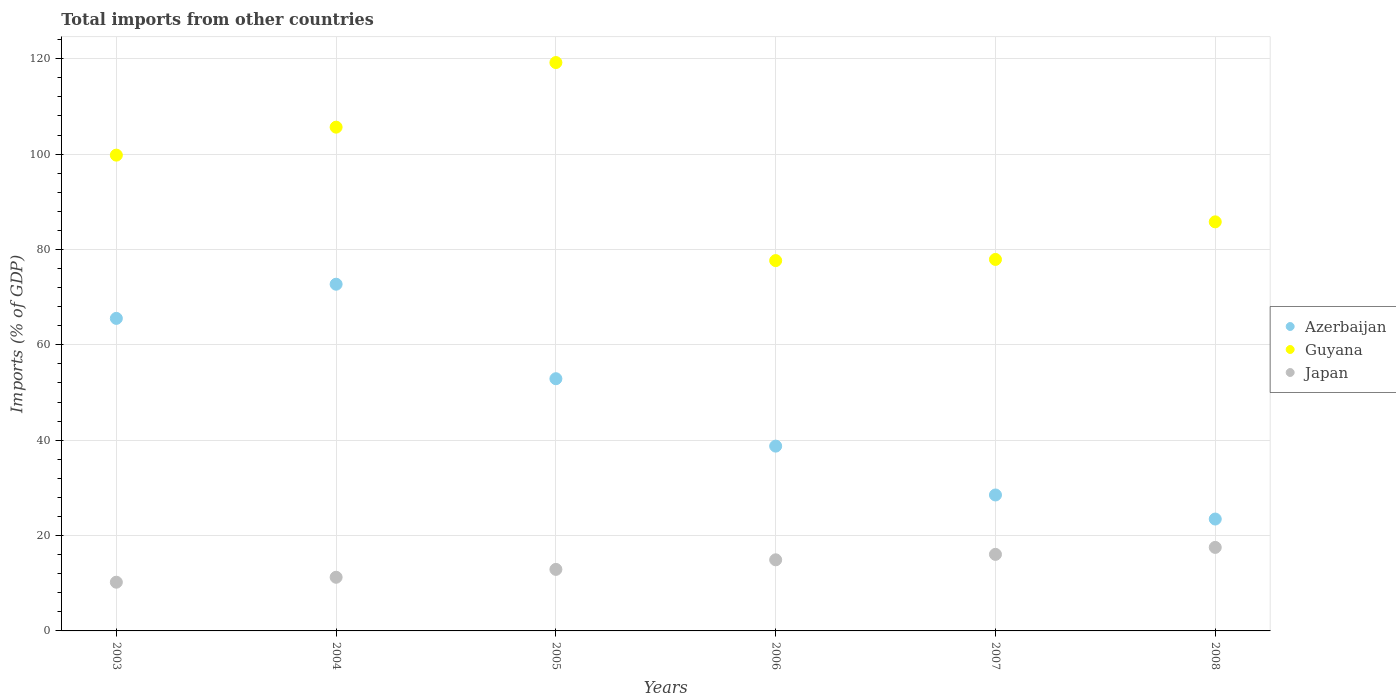How many different coloured dotlines are there?
Keep it short and to the point. 3. What is the total imports in Azerbaijan in 2004?
Offer a very short reply. 72.72. Across all years, what is the maximum total imports in Azerbaijan?
Ensure brevity in your answer.  72.72. Across all years, what is the minimum total imports in Azerbaijan?
Offer a very short reply. 23.47. In which year was the total imports in Japan maximum?
Give a very brief answer. 2008. What is the total total imports in Azerbaijan in the graph?
Your answer should be very brief. 281.9. What is the difference between the total imports in Azerbaijan in 2006 and that in 2008?
Your answer should be compact. 15.29. What is the difference between the total imports in Japan in 2006 and the total imports in Azerbaijan in 2005?
Your answer should be compact. -37.98. What is the average total imports in Japan per year?
Provide a succinct answer. 13.81. In the year 2003, what is the difference between the total imports in Japan and total imports in Guyana?
Offer a terse response. -89.57. In how many years, is the total imports in Azerbaijan greater than 76 %?
Your response must be concise. 0. What is the ratio of the total imports in Japan in 2005 to that in 2007?
Keep it short and to the point. 0.8. Is the total imports in Japan in 2004 less than that in 2008?
Your answer should be compact. Yes. Is the difference between the total imports in Japan in 2006 and 2008 greater than the difference between the total imports in Guyana in 2006 and 2008?
Offer a terse response. Yes. What is the difference between the highest and the second highest total imports in Guyana?
Offer a very short reply. 13.55. What is the difference between the highest and the lowest total imports in Guyana?
Make the answer very short. 41.54. Does the total imports in Azerbaijan monotonically increase over the years?
Offer a very short reply. No. Is the total imports in Japan strictly greater than the total imports in Guyana over the years?
Provide a succinct answer. No. How many years are there in the graph?
Your answer should be very brief. 6. Where does the legend appear in the graph?
Provide a short and direct response. Center right. How are the legend labels stacked?
Ensure brevity in your answer.  Vertical. What is the title of the graph?
Your response must be concise. Total imports from other countries. Does "Central Europe" appear as one of the legend labels in the graph?
Provide a short and direct response. No. What is the label or title of the Y-axis?
Ensure brevity in your answer.  Imports (% of GDP). What is the Imports (% of GDP) of Azerbaijan in 2003?
Provide a short and direct response. 65.55. What is the Imports (% of GDP) in Guyana in 2003?
Keep it short and to the point. 99.79. What is the Imports (% of GDP) in Japan in 2003?
Ensure brevity in your answer.  10.22. What is the Imports (% of GDP) of Azerbaijan in 2004?
Provide a succinct answer. 72.72. What is the Imports (% of GDP) of Guyana in 2004?
Your answer should be very brief. 105.66. What is the Imports (% of GDP) of Japan in 2004?
Give a very brief answer. 11.25. What is the Imports (% of GDP) in Azerbaijan in 2005?
Keep it short and to the point. 52.9. What is the Imports (% of GDP) in Guyana in 2005?
Your answer should be compact. 119.21. What is the Imports (% of GDP) of Japan in 2005?
Provide a succinct answer. 12.9. What is the Imports (% of GDP) in Azerbaijan in 2006?
Offer a terse response. 38.76. What is the Imports (% of GDP) of Guyana in 2006?
Provide a succinct answer. 77.67. What is the Imports (% of GDP) in Japan in 2006?
Ensure brevity in your answer.  14.91. What is the Imports (% of GDP) in Azerbaijan in 2007?
Offer a terse response. 28.51. What is the Imports (% of GDP) in Guyana in 2007?
Give a very brief answer. 77.91. What is the Imports (% of GDP) of Japan in 2007?
Provide a succinct answer. 16.06. What is the Imports (% of GDP) of Azerbaijan in 2008?
Your response must be concise. 23.47. What is the Imports (% of GDP) of Guyana in 2008?
Make the answer very short. 85.8. What is the Imports (% of GDP) of Japan in 2008?
Offer a terse response. 17.52. Across all years, what is the maximum Imports (% of GDP) in Azerbaijan?
Offer a very short reply. 72.72. Across all years, what is the maximum Imports (% of GDP) in Guyana?
Keep it short and to the point. 119.21. Across all years, what is the maximum Imports (% of GDP) of Japan?
Your answer should be very brief. 17.52. Across all years, what is the minimum Imports (% of GDP) in Azerbaijan?
Give a very brief answer. 23.47. Across all years, what is the minimum Imports (% of GDP) of Guyana?
Keep it short and to the point. 77.67. Across all years, what is the minimum Imports (% of GDP) in Japan?
Make the answer very short. 10.22. What is the total Imports (% of GDP) of Azerbaijan in the graph?
Keep it short and to the point. 281.9. What is the total Imports (% of GDP) in Guyana in the graph?
Ensure brevity in your answer.  566.04. What is the total Imports (% of GDP) of Japan in the graph?
Provide a succinct answer. 82.86. What is the difference between the Imports (% of GDP) of Azerbaijan in 2003 and that in 2004?
Provide a short and direct response. -7.17. What is the difference between the Imports (% of GDP) in Guyana in 2003 and that in 2004?
Your answer should be compact. -5.87. What is the difference between the Imports (% of GDP) of Japan in 2003 and that in 2004?
Offer a terse response. -1.04. What is the difference between the Imports (% of GDP) of Azerbaijan in 2003 and that in 2005?
Your answer should be compact. 12.65. What is the difference between the Imports (% of GDP) in Guyana in 2003 and that in 2005?
Offer a terse response. -19.42. What is the difference between the Imports (% of GDP) in Japan in 2003 and that in 2005?
Your response must be concise. -2.69. What is the difference between the Imports (% of GDP) of Azerbaijan in 2003 and that in 2006?
Offer a very short reply. 26.79. What is the difference between the Imports (% of GDP) in Guyana in 2003 and that in 2006?
Provide a succinct answer. 22.12. What is the difference between the Imports (% of GDP) in Japan in 2003 and that in 2006?
Offer a very short reply. -4.7. What is the difference between the Imports (% of GDP) of Azerbaijan in 2003 and that in 2007?
Ensure brevity in your answer.  37.04. What is the difference between the Imports (% of GDP) of Guyana in 2003 and that in 2007?
Ensure brevity in your answer.  21.88. What is the difference between the Imports (% of GDP) in Japan in 2003 and that in 2007?
Provide a short and direct response. -5.84. What is the difference between the Imports (% of GDP) in Azerbaijan in 2003 and that in 2008?
Offer a very short reply. 42.08. What is the difference between the Imports (% of GDP) in Guyana in 2003 and that in 2008?
Your response must be concise. 13.99. What is the difference between the Imports (% of GDP) in Japan in 2003 and that in 2008?
Your response must be concise. -7.3. What is the difference between the Imports (% of GDP) in Azerbaijan in 2004 and that in 2005?
Make the answer very short. 19.82. What is the difference between the Imports (% of GDP) in Guyana in 2004 and that in 2005?
Offer a very short reply. -13.55. What is the difference between the Imports (% of GDP) of Japan in 2004 and that in 2005?
Your response must be concise. -1.65. What is the difference between the Imports (% of GDP) in Azerbaijan in 2004 and that in 2006?
Provide a short and direct response. 33.96. What is the difference between the Imports (% of GDP) in Guyana in 2004 and that in 2006?
Your answer should be compact. 27.99. What is the difference between the Imports (% of GDP) in Japan in 2004 and that in 2006?
Your answer should be very brief. -3.66. What is the difference between the Imports (% of GDP) in Azerbaijan in 2004 and that in 2007?
Your response must be concise. 44.2. What is the difference between the Imports (% of GDP) of Guyana in 2004 and that in 2007?
Your answer should be compact. 27.74. What is the difference between the Imports (% of GDP) of Japan in 2004 and that in 2007?
Offer a terse response. -4.8. What is the difference between the Imports (% of GDP) in Azerbaijan in 2004 and that in 2008?
Offer a very short reply. 49.25. What is the difference between the Imports (% of GDP) in Guyana in 2004 and that in 2008?
Provide a succinct answer. 19.86. What is the difference between the Imports (% of GDP) in Japan in 2004 and that in 2008?
Keep it short and to the point. -6.26. What is the difference between the Imports (% of GDP) of Azerbaijan in 2005 and that in 2006?
Make the answer very short. 14.14. What is the difference between the Imports (% of GDP) of Guyana in 2005 and that in 2006?
Make the answer very short. 41.54. What is the difference between the Imports (% of GDP) of Japan in 2005 and that in 2006?
Provide a succinct answer. -2.01. What is the difference between the Imports (% of GDP) of Azerbaijan in 2005 and that in 2007?
Give a very brief answer. 24.38. What is the difference between the Imports (% of GDP) in Guyana in 2005 and that in 2007?
Your answer should be very brief. 41.29. What is the difference between the Imports (% of GDP) of Japan in 2005 and that in 2007?
Ensure brevity in your answer.  -3.15. What is the difference between the Imports (% of GDP) in Azerbaijan in 2005 and that in 2008?
Make the answer very short. 29.43. What is the difference between the Imports (% of GDP) of Guyana in 2005 and that in 2008?
Your response must be concise. 33.41. What is the difference between the Imports (% of GDP) in Japan in 2005 and that in 2008?
Your answer should be very brief. -4.61. What is the difference between the Imports (% of GDP) in Azerbaijan in 2006 and that in 2007?
Make the answer very short. 10.25. What is the difference between the Imports (% of GDP) in Guyana in 2006 and that in 2007?
Make the answer very short. -0.24. What is the difference between the Imports (% of GDP) of Japan in 2006 and that in 2007?
Offer a very short reply. -1.14. What is the difference between the Imports (% of GDP) of Azerbaijan in 2006 and that in 2008?
Your answer should be very brief. 15.29. What is the difference between the Imports (% of GDP) of Guyana in 2006 and that in 2008?
Offer a terse response. -8.13. What is the difference between the Imports (% of GDP) in Japan in 2006 and that in 2008?
Give a very brief answer. -2.6. What is the difference between the Imports (% of GDP) of Azerbaijan in 2007 and that in 2008?
Provide a succinct answer. 5.05. What is the difference between the Imports (% of GDP) in Guyana in 2007 and that in 2008?
Your response must be concise. -7.88. What is the difference between the Imports (% of GDP) of Japan in 2007 and that in 2008?
Provide a short and direct response. -1.46. What is the difference between the Imports (% of GDP) of Azerbaijan in 2003 and the Imports (% of GDP) of Guyana in 2004?
Provide a short and direct response. -40.11. What is the difference between the Imports (% of GDP) in Azerbaijan in 2003 and the Imports (% of GDP) in Japan in 2004?
Keep it short and to the point. 54.3. What is the difference between the Imports (% of GDP) of Guyana in 2003 and the Imports (% of GDP) of Japan in 2004?
Give a very brief answer. 88.54. What is the difference between the Imports (% of GDP) of Azerbaijan in 2003 and the Imports (% of GDP) of Guyana in 2005?
Offer a very short reply. -53.66. What is the difference between the Imports (% of GDP) of Azerbaijan in 2003 and the Imports (% of GDP) of Japan in 2005?
Keep it short and to the point. 52.65. What is the difference between the Imports (% of GDP) in Guyana in 2003 and the Imports (% of GDP) in Japan in 2005?
Offer a very short reply. 86.89. What is the difference between the Imports (% of GDP) of Azerbaijan in 2003 and the Imports (% of GDP) of Guyana in 2006?
Provide a succinct answer. -12.12. What is the difference between the Imports (% of GDP) of Azerbaijan in 2003 and the Imports (% of GDP) of Japan in 2006?
Your answer should be very brief. 50.64. What is the difference between the Imports (% of GDP) in Guyana in 2003 and the Imports (% of GDP) in Japan in 2006?
Give a very brief answer. 84.88. What is the difference between the Imports (% of GDP) in Azerbaijan in 2003 and the Imports (% of GDP) in Guyana in 2007?
Your response must be concise. -12.36. What is the difference between the Imports (% of GDP) of Azerbaijan in 2003 and the Imports (% of GDP) of Japan in 2007?
Provide a succinct answer. 49.49. What is the difference between the Imports (% of GDP) in Guyana in 2003 and the Imports (% of GDP) in Japan in 2007?
Your answer should be compact. 83.73. What is the difference between the Imports (% of GDP) of Azerbaijan in 2003 and the Imports (% of GDP) of Guyana in 2008?
Keep it short and to the point. -20.25. What is the difference between the Imports (% of GDP) in Azerbaijan in 2003 and the Imports (% of GDP) in Japan in 2008?
Keep it short and to the point. 48.03. What is the difference between the Imports (% of GDP) in Guyana in 2003 and the Imports (% of GDP) in Japan in 2008?
Give a very brief answer. 82.27. What is the difference between the Imports (% of GDP) of Azerbaijan in 2004 and the Imports (% of GDP) of Guyana in 2005?
Provide a short and direct response. -46.49. What is the difference between the Imports (% of GDP) in Azerbaijan in 2004 and the Imports (% of GDP) in Japan in 2005?
Provide a succinct answer. 59.81. What is the difference between the Imports (% of GDP) of Guyana in 2004 and the Imports (% of GDP) of Japan in 2005?
Your answer should be compact. 92.75. What is the difference between the Imports (% of GDP) in Azerbaijan in 2004 and the Imports (% of GDP) in Guyana in 2006?
Ensure brevity in your answer.  -4.95. What is the difference between the Imports (% of GDP) of Azerbaijan in 2004 and the Imports (% of GDP) of Japan in 2006?
Your answer should be compact. 57.8. What is the difference between the Imports (% of GDP) in Guyana in 2004 and the Imports (% of GDP) in Japan in 2006?
Make the answer very short. 90.74. What is the difference between the Imports (% of GDP) of Azerbaijan in 2004 and the Imports (% of GDP) of Guyana in 2007?
Offer a very short reply. -5.2. What is the difference between the Imports (% of GDP) of Azerbaijan in 2004 and the Imports (% of GDP) of Japan in 2007?
Make the answer very short. 56.66. What is the difference between the Imports (% of GDP) of Guyana in 2004 and the Imports (% of GDP) of Japan in 2007?
Your answer should be compact. 89.6. What is the difference between the Imports (% of GDP) in Azerbaijan in 2004 and the Imports (% of GDP) in Guyana in 2008?
Ensure brevity in your answer.  -13.08. What is the difference between the Imports (% of GDP) in Azerbaijan in 2004 and the Imports (% of GDP) in Japan in 2008?
Your response must be concise. 55.2. What is the difference between the Imports (% of GDP) of Guyana in 2004 and the Imports (% of GDP) of Japan in 2008?
Offer a terse response. 88.14. What is the difference between the Imports (% of GDP) of Azerbaijan in 2005 and the Imports (% of GDP) of Guyana in 2006?
Make the answer very short. -24.77. What is the difference between the Imports (% of GDP) in Azerbaijan in 2005 and the Imports (% of GDP) in Japan in 2006?
Your answer should be very brief. 37.98. What is the difference between the Imports (% of GDP) in Guyana in 2005 and the Imports (% of GDP) in Japan in 2006?
Keep it short and to the point. 104.29. What is the difference between the Imports (% of GDP) of Azerbaijan in 2005 and the Imports (% of GDP) of Guyana in 2007?
Your answer should be very brief. -25.02. What is the difference between the Imports (% of GDP) of Azerbaijan in 2005 and the Imports (% of GDP) of Japan in 2007?
Provide a succinct answer. 36.84. What is the difference between the Imports (% of GDP) in Guyana in 2005 and the Imports (% of GDP) in Japan in 2007?
Ensure brevity in your answer.  103.15. What is the difference between the Imports (% of GDP) of Azerbaijan in 2005 and the Imports (% of GDP) of Guyana in 2008?
Provide a succinct answer. -32.9. What is the difference between the Imports (% of GDP) of Azerbaijan in 2005 and the Imports (% of GDP) of Japan in 2008?
Make the answer very short. 35.38. What is the difference between the Imports (% of GDP) of Guyana in 2005 and the Imports (% of GDP) of Japan in 2008?
Provide a short and direct response. 101.69. What is the difference between the Imports (% of GDP) of Azerbaijan in 2006 and the Imports (% of GDP) of Guyana in 2007?
Offer a very short reply. -39.16. What is the difference between the Imports (% of GDP) in Azerbaijan in 2006 and the Imports (% of GDP) in Japan in 2007?
Your answer should be compact. 22.7. What is the difference between the Imports (% of GDP) in Guyana in 2006 and the Imports (% of GDP) in Japan in 2007?
Your answer should be compact. 61.61. What is the difference between the Imports (% of GDP) of Azerbaijan in 2006 and the Imports (% of GDP) of Guyana in 2008?
Ensure brevity in your answer.  -47.04. What is the difference between the Imports (% of GDP) of Azerbaijan in 2006 and the Imports (% of GDP) of Japan in 2008?
Make the answer very short. 21.24. What is the difference between the Imports (% of GDP) in Guyana in 2006 and the Imports (% of GDP) in Japan in 2008?
Offer a very short reply. 60.15. What is the difference between the Imports (% of GDP) of Azerbaijan in 2007 and the Imports (% of GDP) of Guyana in 2008?
Your response must be concise. -57.28. What is the difference between the Imports (% of GDP) in Azerbaijan in 2007 and the Imports (% of GDP) in Japan in 2008?
Your response must be concise. 11. What is the difference between the Imports (% of GDP) in Guyana in 2007 and the Imports (% of GDP) in Japan in 2008?
Offer a very short reply. 60.4. What is the average Imports (% of GDP) of Azerbaijan per year?
Provide a succinct answer. 46.98. What is the average Imports (% of GDP) of Guyana per year?
Make the answer very short. 94.34. What is the average Imports (% of GDP) of Japan per year?
Offer a terse response. 13.81. In the year 2003, what is the difference between the Imports (% of GDP) in Azerbaijan and Imports (% of GDP) in Guyana?
Offer a terse response. -34.24. In the year 2003, what is the difference between the Imports (% of GDP) in Azerbaijan and Imports (% of GDP) in Japan?
Your response must be concise. 55.33. In the year 2003, what is the difference between the Imports (% of GDP) in Guyana and Imports (% of GDP) in Japan?
Your answer should be very brief. 89.57. In the year 2004, what is the difference between the Imports (% of GDP) in Azerbaijan and Imports (% of GDP) in Guyana?
Your response must be concise. -32.94. In the year 2004, what is the difference between the Imports (% of GDP) of Azerbaijan and Imports (% of GDP) of Japan?
Ensure brevity in your answer.  61.46. In the year 2004, what is the difference between the Imports (% of GDP) of Guyana and Imports (% of GDP) of Japan?
Offer a terse response. 94.4. In the year 2005, what is the difference between the Imports (% of GDP) in Azerbaijan and Imports (% of GDP) in Guyana?
Offer a terse response. -66.31. In the year 2005, what is the difference between the Imports (% of GDP) in Azerbaijan and Imports (% of GDP) in Japan?
Give a very brief answer. 39.99. In the year 2005, what is the difference between the Imports (% of GDP) in Guyana and Imports (% of GDP) in Japan?
Make the answer very short. 106.3. In the year 2006, what is the difference between the Imports (% of GDP) in Azerbaijan and Imports (% of GDP) in Guyana?
Your response must be concise. -38.91. In the year 2006, what is the difference between the Imports (% of GDP) in Azerbaijan and Imports (% of GDP) in Japan?
Keep it short and to the point. 23.84. In the year 2006, what is the difference between the Imports (% of GDP) of Guyana and Imports (% of GDP) of Japan?
Give a very brief answer. 62.76. In the year 2007, what is the difference between the Imports (% of GDP) in Azerbaijan and Imports (% of GDP) in Guyana?
Ensure brevity in your answer.  -49.4. In the year 2007, what is the difference between the Imports (% of GDP) of Azerbaijan and Imports (% of GDP) of Japan?
Offer a very short reply. 12.46. In the year 2007, what is the difference between the Imports (% of GDP) in Guyana and Imports (% of GDP) in Japan?
Give a very brief answer. 61.86. In the year 2008, what is the difference between the Imports (% of GDP) in Azerbaijan and Imports (% of GDP) in Guyana?
Give a very brief answer. -62.33. In the year 2008, what is the difference between the Imports (% of GDP) in Azerbaijan and Imports (% of GDP) in Japan?
Your answer should be compact. 5.95. In the year 2008, what is the difference between the Imports (% of GDP) in Guyana and Imports (% of GDP) in Japan?
Give a very brief answer. 68.28. What is the ratio of the Imports (% of GDP) of Azerbaijan in 2003 to that in 2004?
Offer a terse response. 0.9. What is the ratio of the Imports (% of GDP) in Guyana in 2003 to that in 2004?
Offer a terse response. 0.94. What is the ratio of the Imports (% of GDP) of Japan in 2003 to that in 2004?
Your answer should be compact. 0.91. What is the ratio of the Imports (% of GDP) of Azerbaijan in 2003 to that in 2005?
Your answer should be compact. 1.24. What is the ratio of the Imports (% of GDP) in Guyana in 2003 to that in 2005?
Ensure brevity in your answer.  0.84. What is the ratio of the Imports (% of GDP) in Japan in 2003 to that in 2005?
Your answer should be very brief. 0.79. What is the ratio of the Imports (% of GDP) of Azerbaijan in 2003 to that in 2006?
Offer a very short reply. 1.69. What is the ratio of the Imports (% of GDP) in Guyana in 2003 to that in 2006?
Provide a short and direct response. 1.28. What is the ratio of the Imports (% of GDP) of Japan in 2003 to that in 2006?
Give a very brief answer. 0.69. What is the ratio of the Imports (% of GDP) in Azerbaijan in 2003 to that in 2007?
Provide a succinct answer. 2.3. What is the ratio of the Imports (% of GDP) of Guyana in 2003 to that in 2007?
Provide a succinct answer. 1.28. What is the ratio of the Imports (% of GDP) of Japan in 2003 to that in 2007?
Your answer should be very brief. 0.64. What is the ratio of the Imports (% of GDP) in Azerbaijan in 2003 to that in 2008?
Offer a very short reply. 2.79. What is the ratio of the Imports (% of GDP) of Guyana in 2003 to that in 2008?
Keep it short and to the point. 1.16. What is the ratio of the Imports (% of GDP) of Japan in 2003 to that in 2008?
Ensure brevity in your answer.  0.58. What is the ratio of the Imports (% of GDP) in Azerbaijan in 2004 to that in 2005?
Give a very brief answer. 1.37. What is the ratio of the Imports (% of GDP) of Guyana in 2004 to that in 2005?
Ensure brevity in your answer.  0.89. What is the ratio of the Imports (% of GDP) in Japan in 2004 to that in 2005?
Offer a very short reply. 0.87. What is the ratio of the Imports (% of GDP) of Azerbaijan in 2004 to that in 2006?
Provide a short and direct response. 1.88. What is the ratio of the Imports (% of GDP) of Guyana in 2004 to that in 2006?
Your answer should be very brief. 1.36. What is the ratio of the Imports (% of GDP) in Japan in 2004 to that in 2006?
Your answer should be compact. 0.75. What is the ratio of the Imports (% of GDP) of Azerbaijan in 2004 to that in 2007?
Offer a very short reply. 2.55. What is the ratio of the Imports (% of GDP) in Guyana in 2004 to that in 2007?
Provide a short and direct response. 1.36. What is the ratio of the Imports (% of GDP) in Japan in 2004 to that in 2007?
Provide a short and direct response. 0.7. What is the ratio of the Imports (% of GDP) in Azerbaijan in 2004 to that in 2008?
Offer a very short reply. 3.1. What is the ratio of the Imports (% of GDP) of Guyana in 2004 to that in 2008?
Make the answer very short. 1.23. What is the ratio of the Imports (% of GDP) of Japan in 2004 to that in 2008?
Keep it short and to the point. 0.64. What is the ratio of the Imports (% of GDP) of Azerbaijan in 2005 to that in 2006?
Your answer should be very brief. 1.36. What is the ratio of the Imports (% of GDP) of Guyana in 2005 to that in 2006?
Your answer should be very brief. 1.53. What is the ratio of the Imports (% of GDP) in Japan in 2005 to that in 2006?
Keep it short and to the point. 0.87. What is the ratio of the Imports (% of GDP) in Azerbaijan in 2005 to that in 2007?
Your answer should be compact. 1.86. What is the ratio of the Imports (% of GDP) of Guyana in 2005 to that in 2007?
Offer a terse response. 1.53. What is the ratio of the Imports (% of GDP) of Japan in 2005 to that in 2007?
Provide a short and direct response. 0.8. What is the ratio of the Imports (% of GDP) in Azerbaijan in 2005 to that in 2008?
Keep it short and to the point. 2.25. What is the ratio of the Imports (% of GDP) in Guyana in 2005 to that in 2008?
Your answer should be very brief. 1.39. What is the ratio of the Imports (% of GDP) in Japan in 2005 to that in 2008?
Your answer should be very brief. 0.74. What is the ratio of the Imports (% of GDP) in Azerbaijan in 2006 to that in 2007?
Offer a very short reply. 1.36. What is the ratio of the Imports (% of GDP) of Guyana in 2006 to that in 2007?
Give a very brief answer. 1. What is the ratio of the Imports (% of GDP) of Japan in 2006 to that in 2007?
Your answer should be compact. 0.93. What is the ratio of the Imports (% of GDP) of Azerbaijan in 2006 to that in 2008?
Ensure brevity in your answer.  1.65. What is the ratio of the Imports (% of GDP) in Guyana in 2006 to that in 2008?
Give a very brief answer. 0.91. What is the ratio of the Imports (% of GDP) of Japan in 2006 to that in 2008?
Your answer should be very brief. 0.85. What is the ratio of the Imports (% of GDP) in Azerbaijan in 2007 to that in 2008?
Offer a very short reply. 1.22. What is the ratio of the Imports (% of GDP) in Guyana in 2007 to that in 2008?
Offer a terse response. 0.91. What is the ratio of the Imports (% of GDP) of Japan in 2007 to that in 2008?
Your response must be concise. 0.92. What is the difference between the highest and the second highest Imports (% of GDP) of Azerbaijan?
Provide a short and direct response. 7.17. What is the difference between the highest and the second highest Imports (% of GDP) of Guyana?
Your answer should be very brief. 13.55. What is the difference between the highest and the second highest Imports (% of GDP) of Japan?
Offer a terse response. 1.46. What is the difference between the highest and the lowest Imports (% of GDP) in Azerbaijan?
Make the answer very short. 49.25. What is the difference between the highest and the lowest Imports (% of GDP) of Guyana?
Provide a succinct answer. 41.54. What is the difference between the highest and the lowest Imports (% of GDP) in Japan?
Your response must be concise. 7.3. 